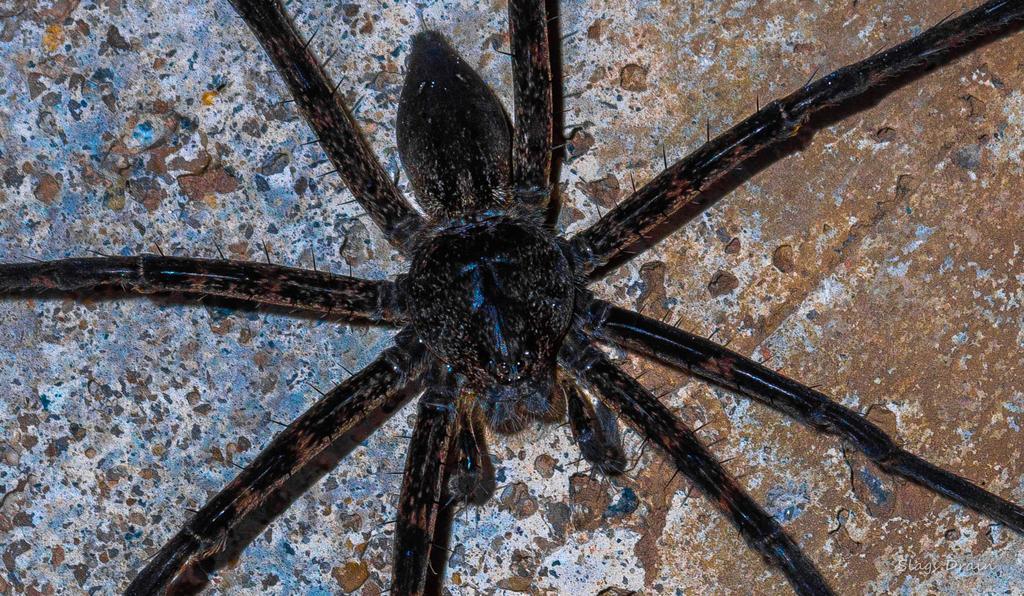Please provide a concise description of this image. In the center of the image we can see a spider. 